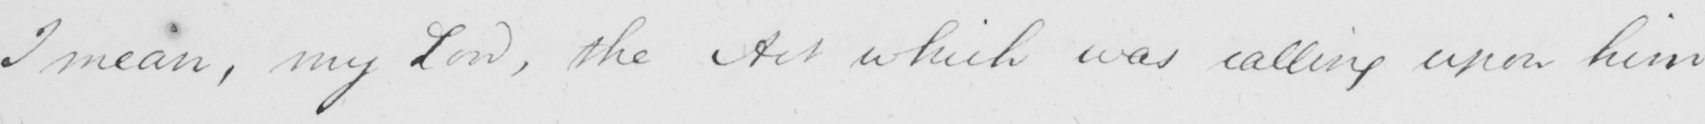Please provide the text content of this handwritten line. I mean , my Lord , the Act which was calling upon him 